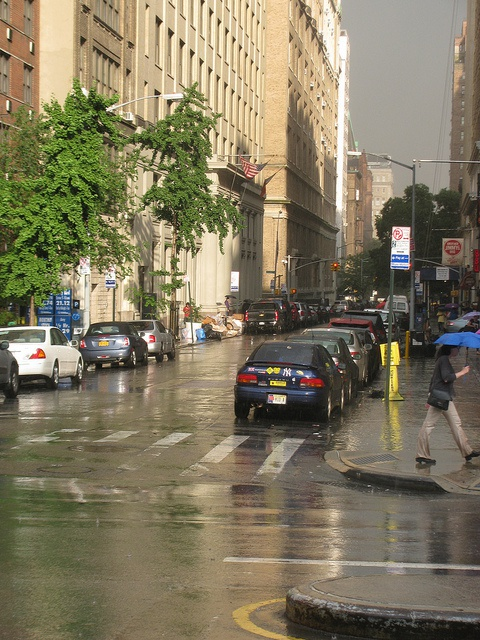Describe the objects in this image and their specific colors. I can see car in black, gray, and maroon tones, car in black, white, gray, and darkgray tones, people in black, gray, and darkgray tones, car in black, gray, and darkgray tones, and car in black, gray, and maroon tones in this image. 